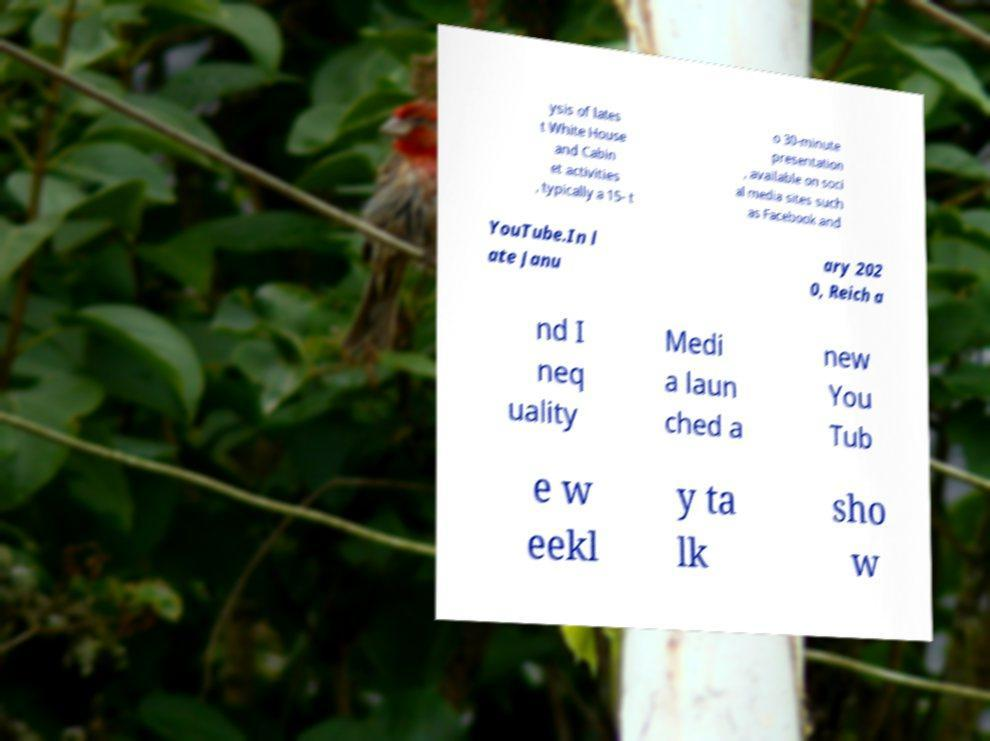For documentation purposes, I need the text within this image transcribed. Could you provide that? ysis of lates t White House and Cabin et activities , typically a 15- t o 30-minute presentation , available on soci al media sites such as Facebook and YouTube.In l ate Janu ary 202 0, Reich a nd I neq uality Medi a laun ched a new You Tub e w eekl y ta lk sho w 